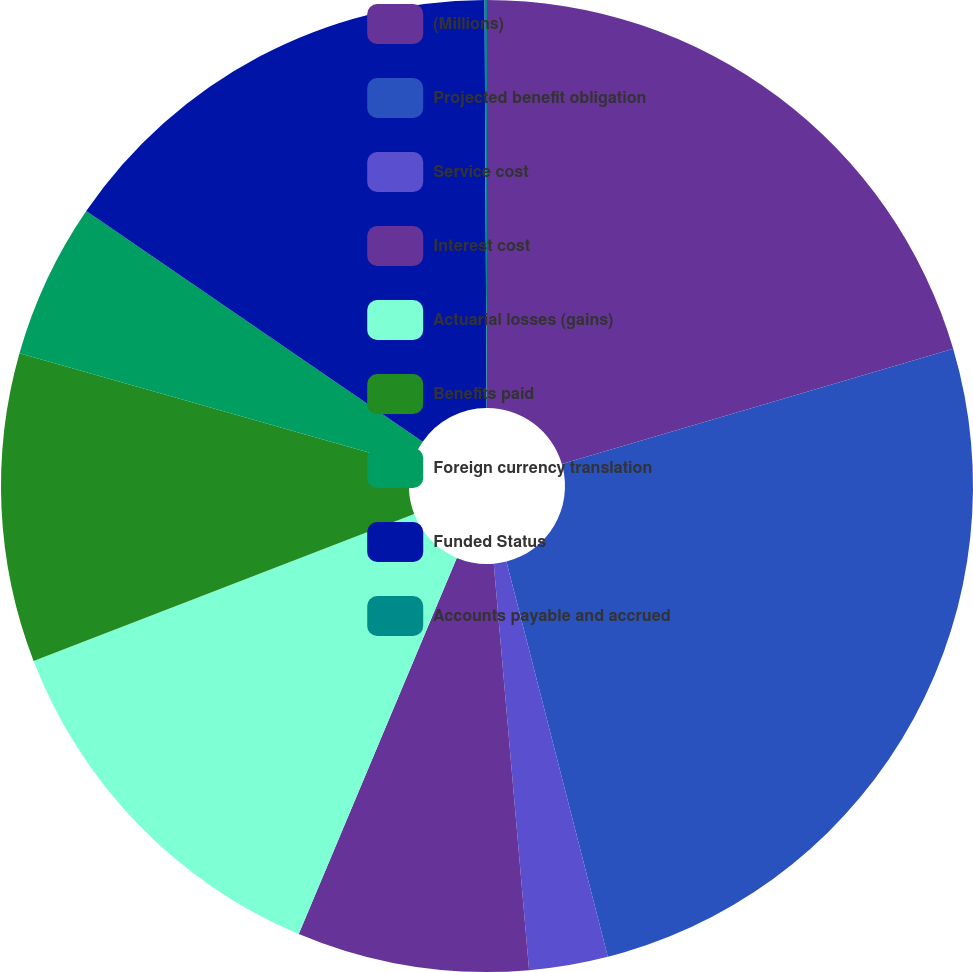Convert chart to OTSL. <chart><loc_0><loc_0><loc_500><loc_500><pie_chart><fcel>(Millions)<fcel>Projected benefit obligation<fcel>Service cost<fcel>Interest cost<fcel>Actuarial losses (gains)<fcel>Benefits paid<fcel>Foreign currency translation<fcel>Funded Status<fcel>Accounts payable and accrued<nl><fcel>20.44%<fcel>25.56%<fcel>2.62%<fcel>7.71%<fcel>12.81%<fcel>10.26%<fcel>5.17%<fcel>15.35%<fcel>0.08%<nl></chart> 